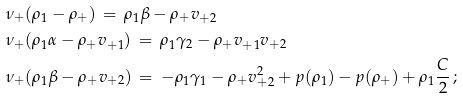<formula> <loc_0><loc_0><loc_500><loc_500>& \nu _ { + } ( \rho _ { 1 } - \rho _ { + } ) \, = \, \rho _ { 1 } \beta - \rho _ { + } v _ { + 2 } \\ & \nu _ { + } ( \rho _ { 1 } \alpha - \rho _ { + } v _ { + 1 } ) \, = \, \rho _ { 1 } \gamma _ { 2 } - \rho _ { + } v _ { + 1 } v _ { + 2 } \\ & \nu _ { + } ( \rho _ { 1 } \beta - \rho _ { + } v _ { + 2 } ) \, = \, - \rho _ { 1 } \gamma _ { 1 } - \rho _ { + } v _ { + 2 } ^ { 2 } + p ( \rho _ { 1 } ) - p ( \rho _ { + } ) + \rho _ { 1 } \frac { C } { 2 } \, ;</formula> 